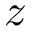Convert formula to latex. <formula><loc_0><loc_0><loc_500><loc_500>z</formula> 